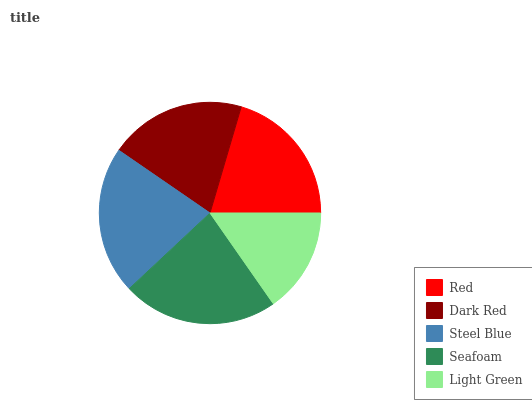Is Light Green the minimum?
Answer yes or no. Yes. Is Seafoam the maximum?
Answer yes or no. Yes. Is Dark Red the minimum?
Answer yes or no. No. Is Dark Red the maximum?
Answer yes or no. No. Is Red greater than Dark Red?
Answer yes or no. Yes. Is Dark Red less than Red?
Answer yes or no. Yes. Is Dark Red greater than Red?
Answer yes or no. No. Is Red less than Dark Red?
Answer yes or no. No. Is Red the high median?
Answer yes or no. Yes. Is Red the low median?
Answer yes or no. Yes. Is Light Green the high median?
Answer yes or no. No. Is Steel Blue the low median?
Answer yes or no. No. 